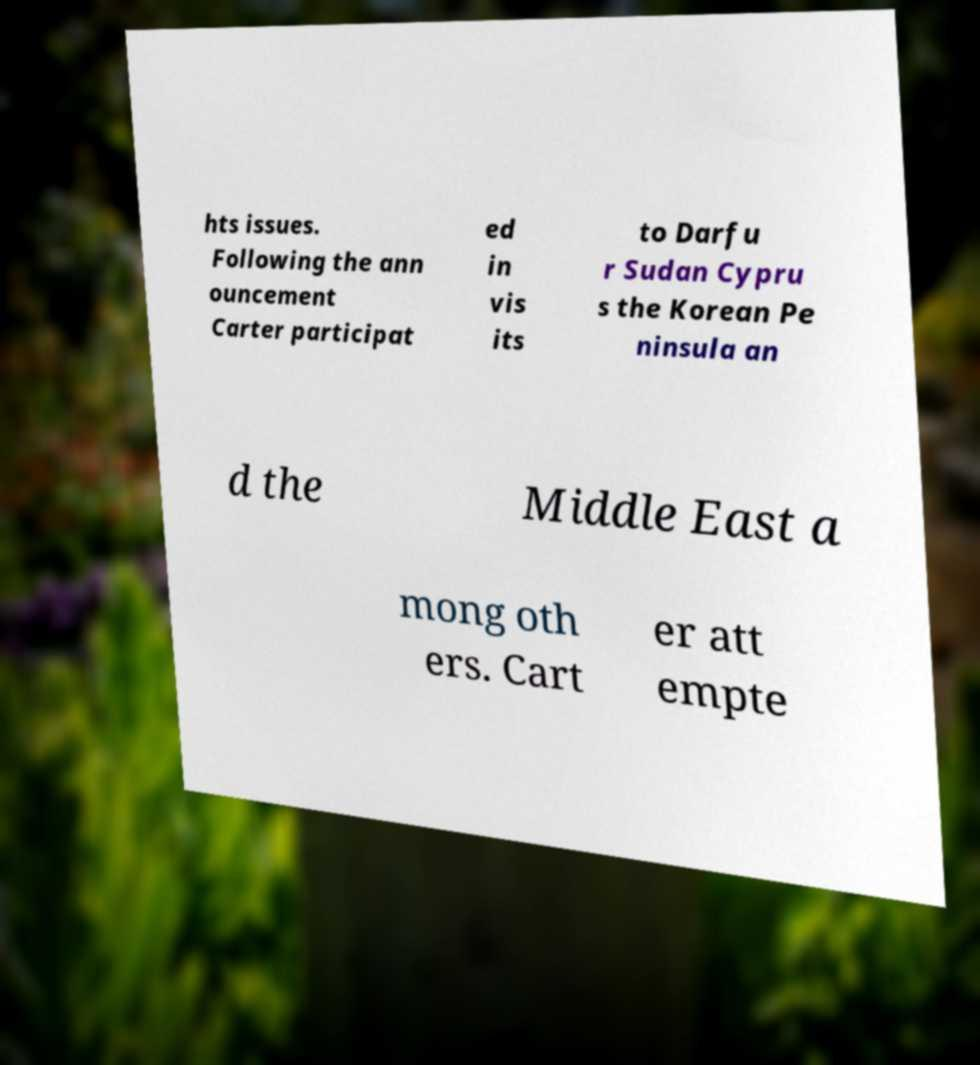There's text embedded in this image that I need extracted. Can you transcribe it verbatim? hts issues. Following the ann ouncement Carter participat ed in vis its to Darfu r Sudan Cypru s the Korean Pe ninsula an d the Middle East a mong oth ers. Cart er att empte 